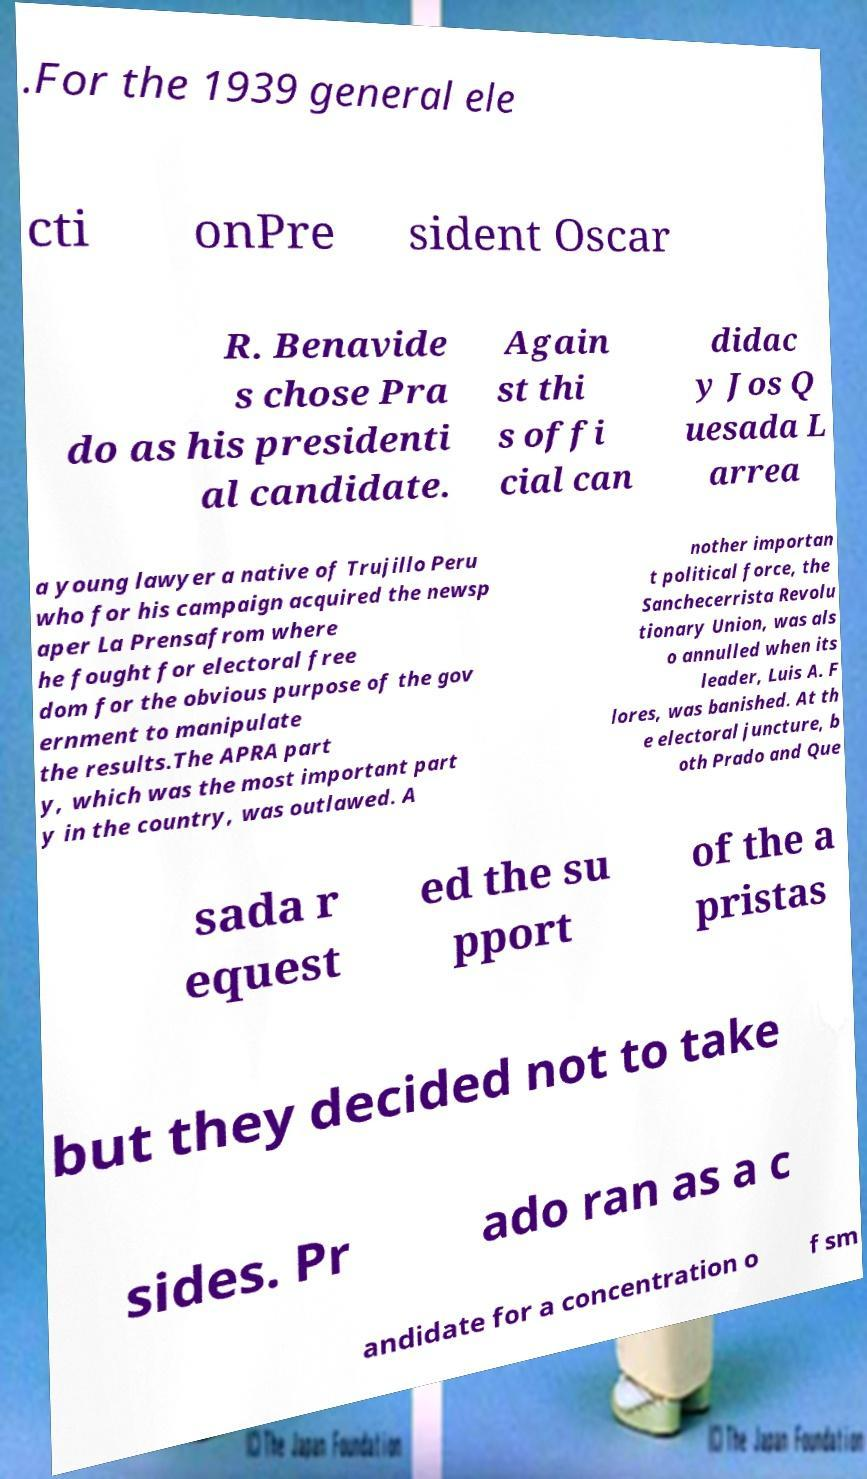Can you read and provide the text displayed in the image?This photo seems to have some interesting text. Can you extract and type it out for me? .For the 1939 general ele cti onPre sident Oscar R. Benavide s chose Pra do as his presidenti al candidate. Again st thi s offi cial can didac y Jos Q uesada L arrea a young lawyer a native of Trujillo Peru who for his campaign acquired the newsp aper La Prensafrom where he fought for electoral free dom for the obvious purpose of the gov ernment to manipulate the results.The APRA part y, which was the most important part y in the country, was outlawed. A nother importan t political force, the Sanchecerrista Revolu tionary Union, was als o annulled when its leader, Luis A. F lores, was banished. At th e electoral juncture, b oth Prado and Que sada r equest ed the su pport of the a pristas but they decided not to take sides. Pr ado ran as a c andidate for a concentration o f sm 